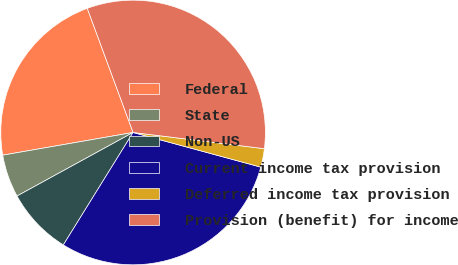Convert chart to OTSL. <chart><loc_0><loc_0><loc_500><loc_500><pie_chart><fcel>Federal<fcel>State<fcel>Non-US<fcel>Current income tax provision<fcel>Deferred income tax provision<fcel>Provision (benefit) for income<nl><fcel>22.12%<fcel>5.23%<fcel>8.19%<fcel>29.62%<fcel>2.26%<fcel>32.58%<nl></chart> 